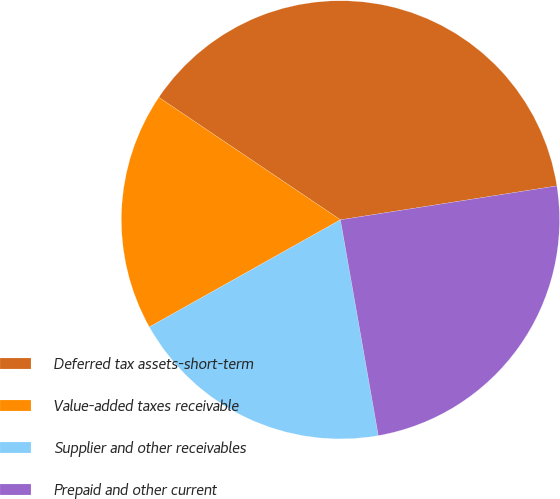Convert chart. <chart><loc_0><loc_0><loc_500><loc_500><pie_chart><fcel>Deferred tax assets-short-term<fcel>Value-added taxes receivable<fcel>Supplier and other receivables<fcel>Prepaid and other current<nl><fcel>38.09%<fcel>17.58%<fcel>19.63%<fcel>24.71%<nl></chart> 